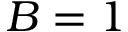Convert formula to latex. <formula><loc_0><loc_0><loc_500><loc_500>B = 1</formula> 